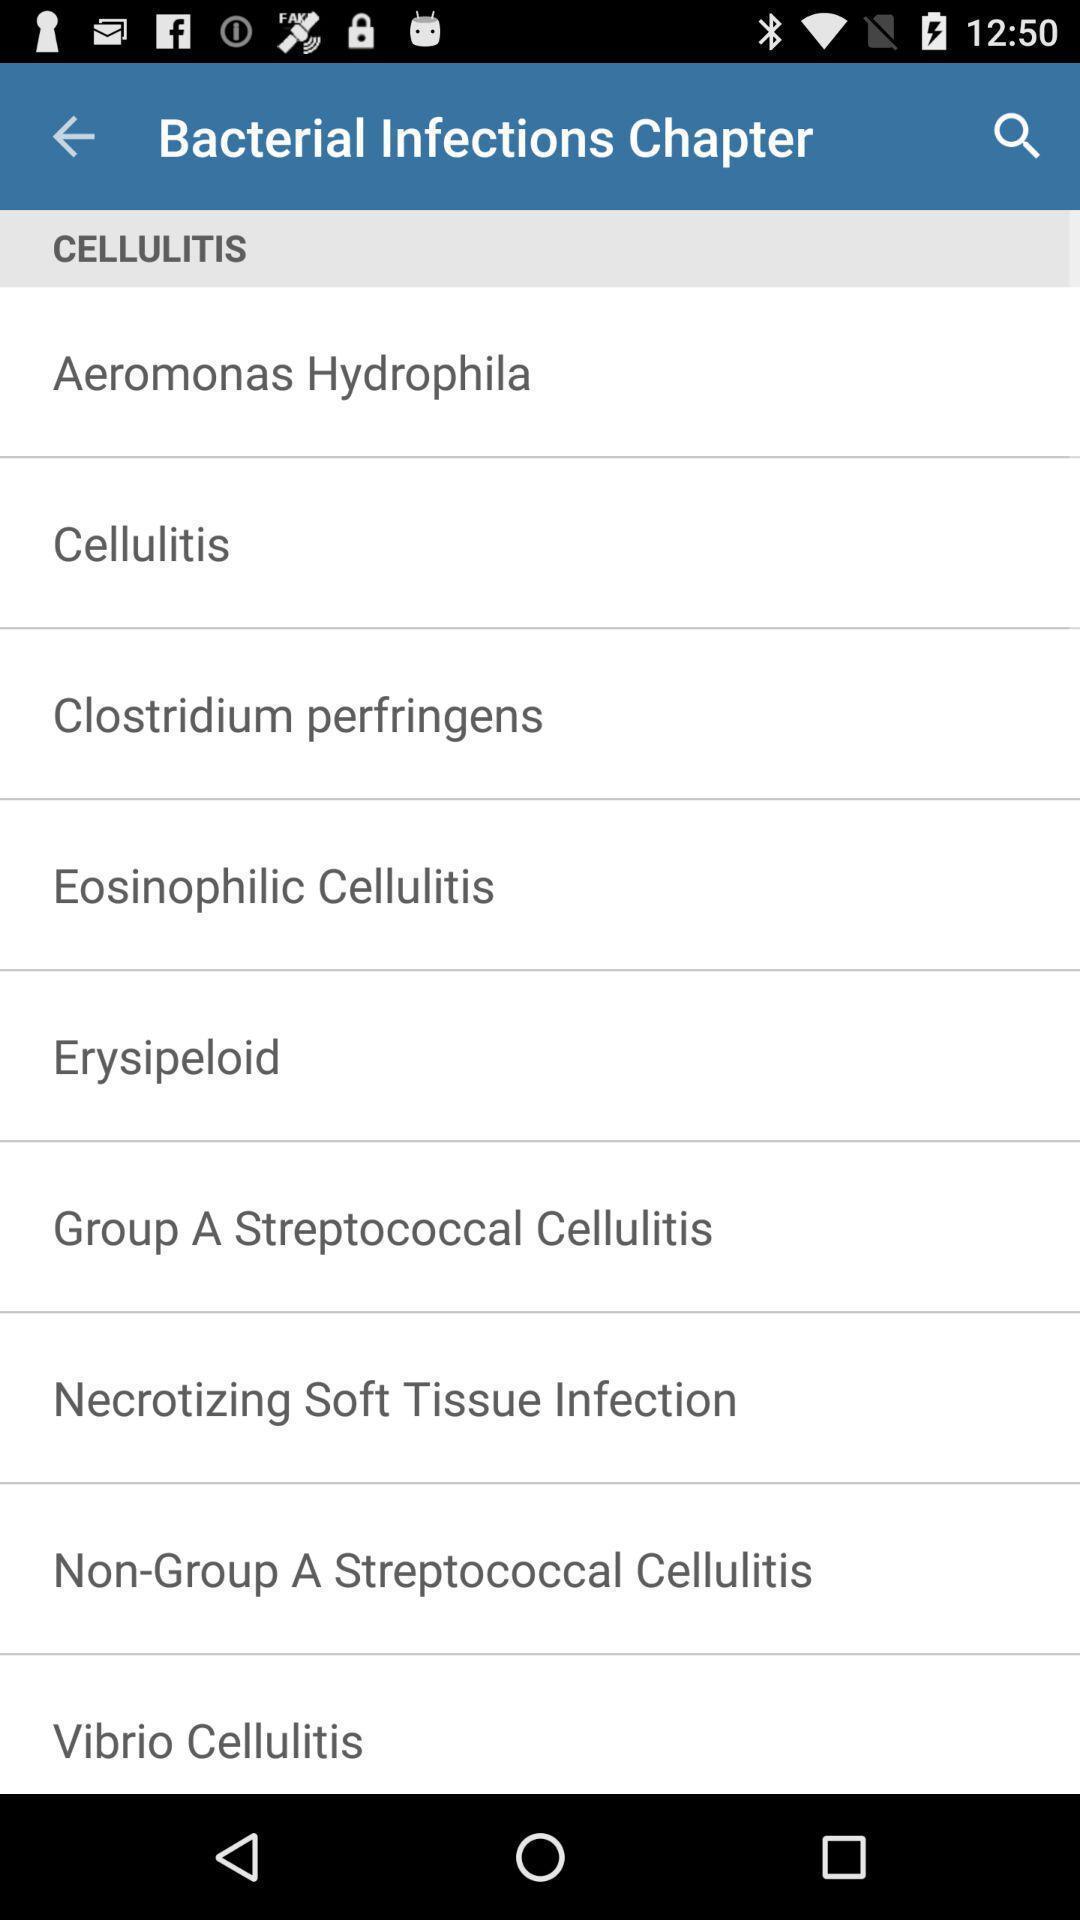Describe the visual elements of this screenshot. Screen displaying list of chapters regarding bacterial infections. 